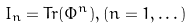Convert formula to latex. <formula><loc_0><loc_0><loc_500><loc_500>I _ { n } = T r ( \Phi ^ { n } ) , ( n = 1 , \dots )</formula> 